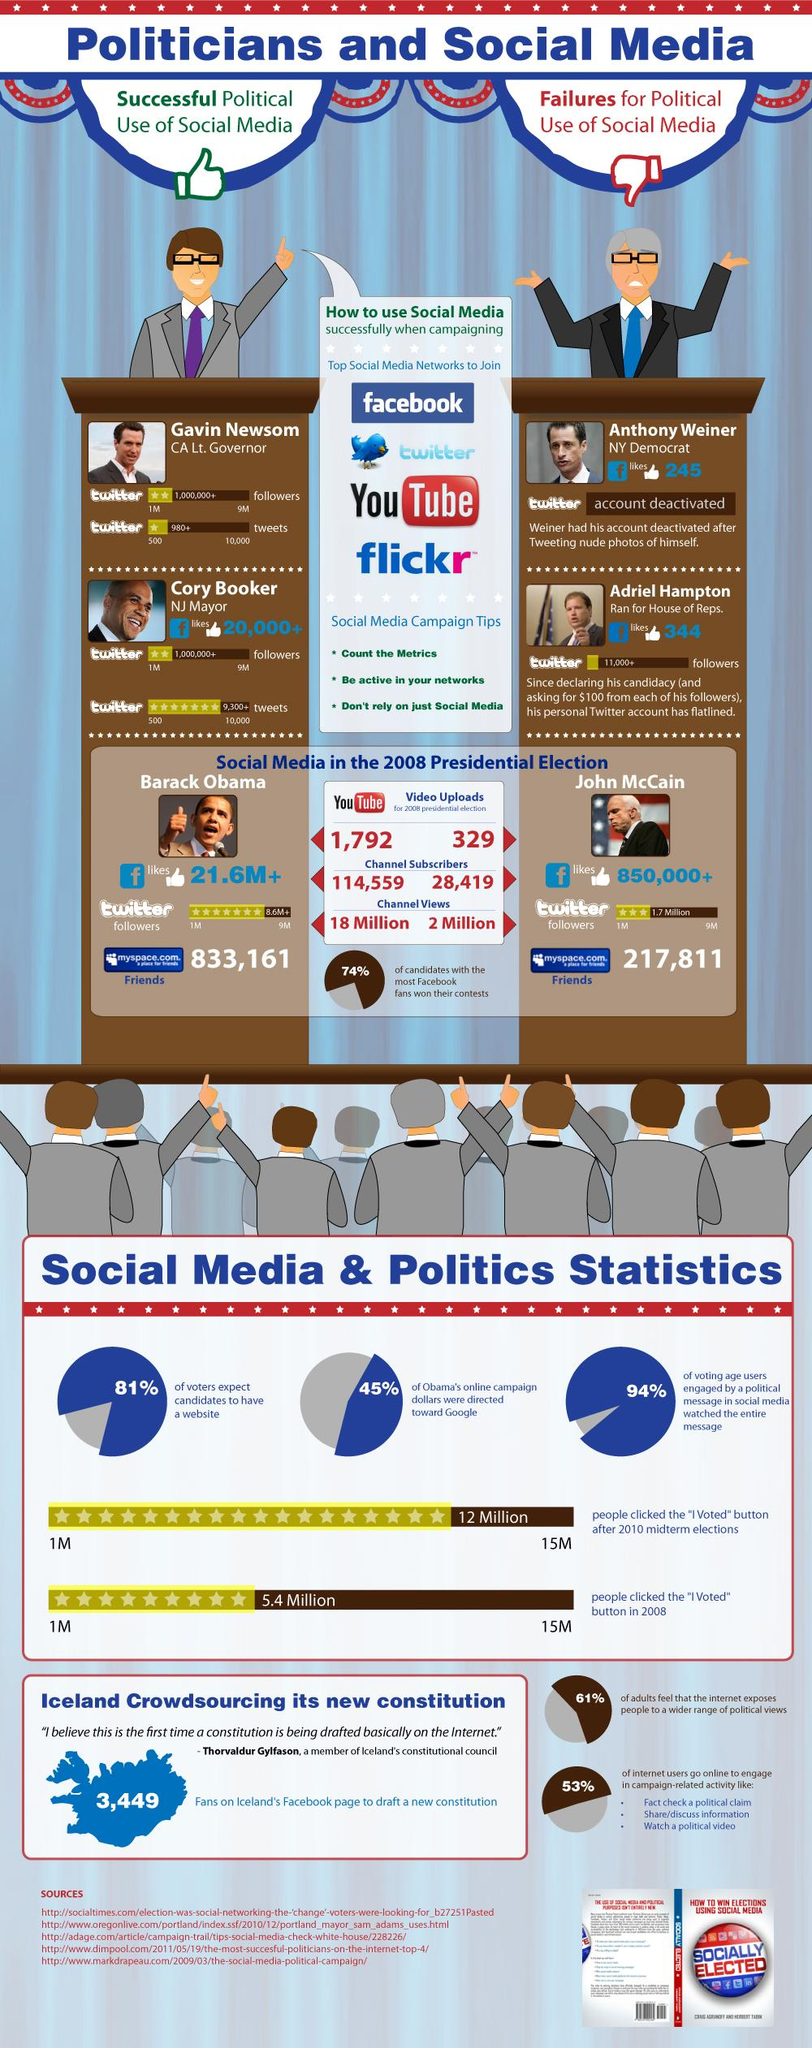Identify some key points in this picture. Whoever's details do not have any Facebook likes is Gavin Newsom. A significant percentage of voters do not expect candidates to have a website, as stated by the information given. Barack Obama has over 8.6 million Twitter followers. Adriel Hampton asked each of his followers for $100. According to the survey, a significant percentage of adults do not believe that the internet provides access to a wider range of political views. Specifically, 39% of adults hold this view. 